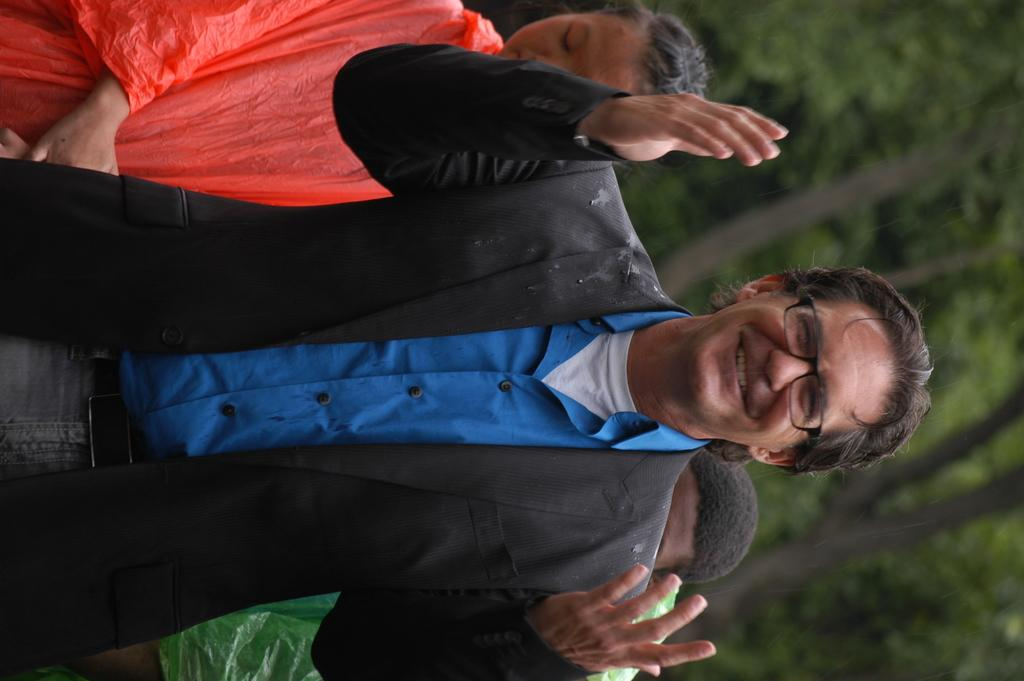Who is present in the image? There is a person in the image. What is the person doing in the image? The person is smiling. What accessory is the person wearing in the image? The person is wearing spectacles. What can be seen in the background of the image? There are people and trees in the background of the image. What flavor of yarn is the person holding in the image? There is no yarn present in the image, and therefore no flavor can be determined. 